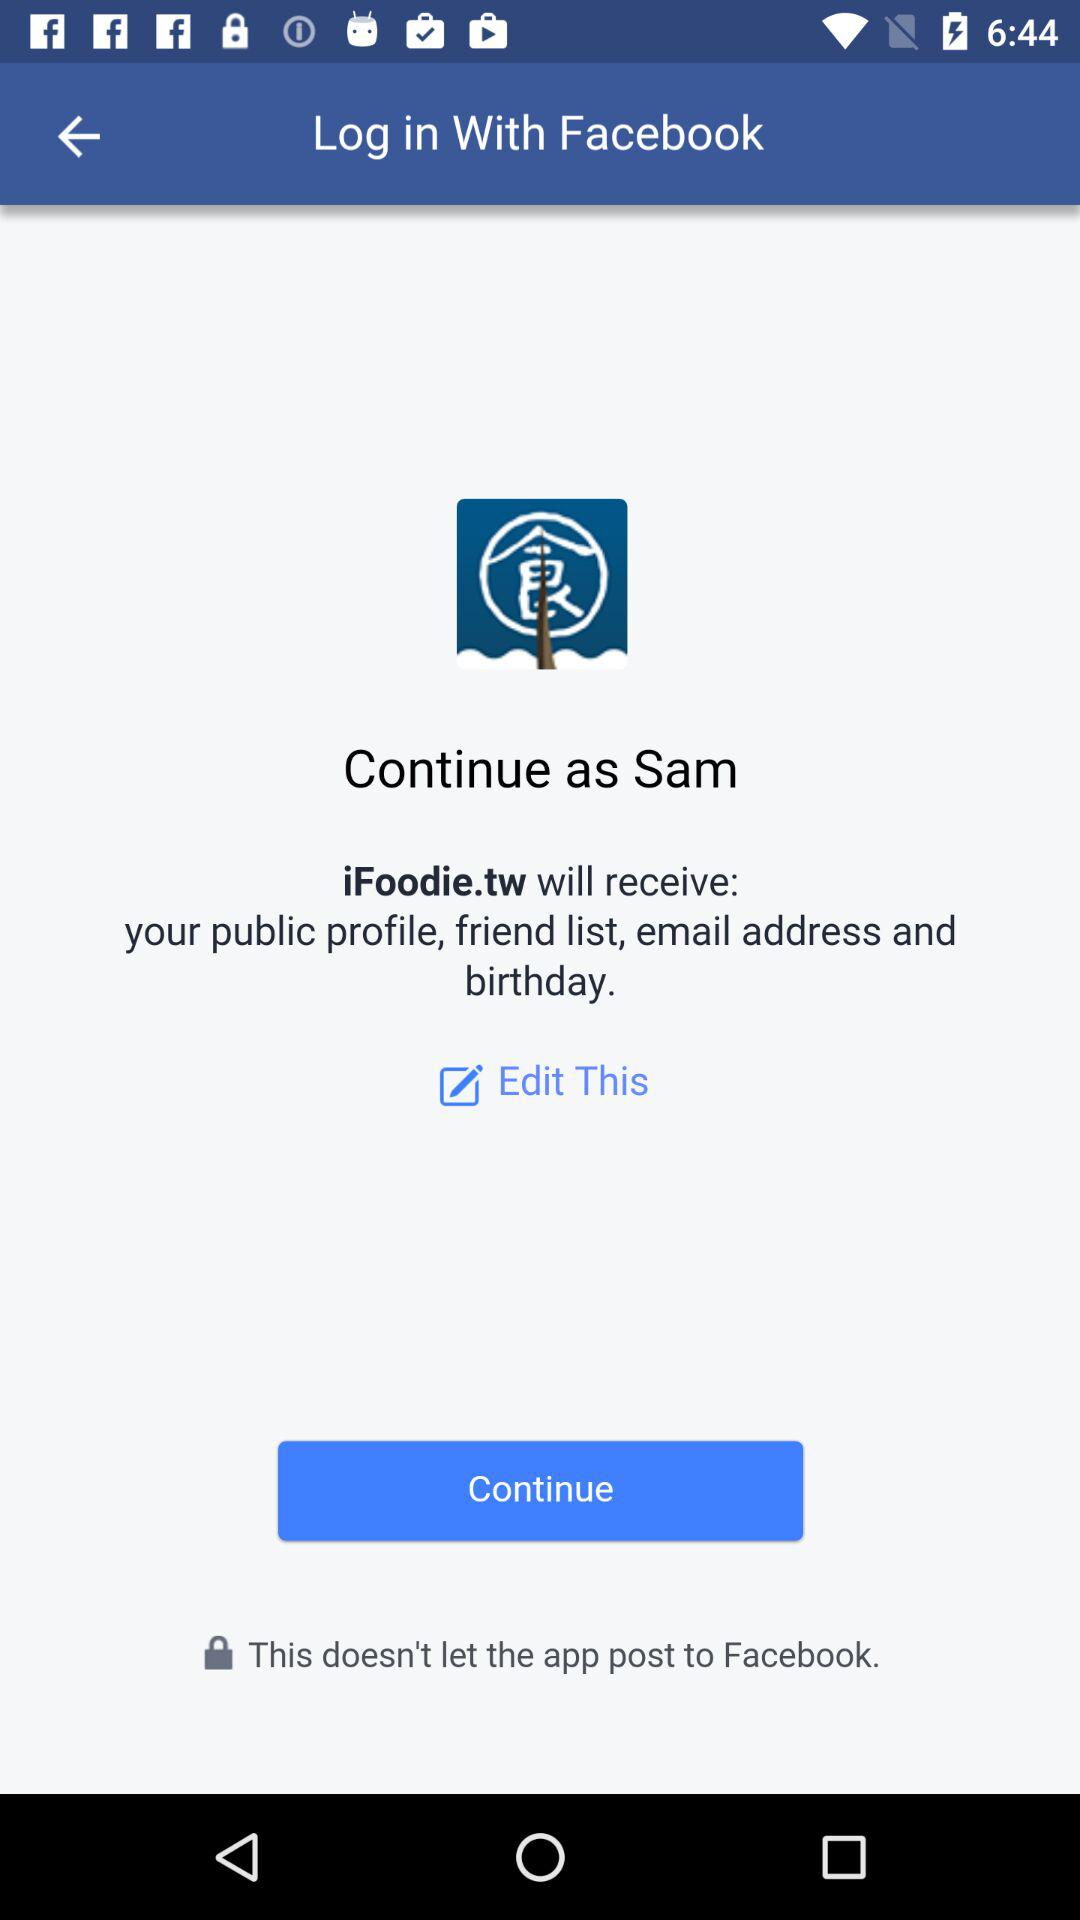What information will "iFoodie.tw" receive? "iFoodie.tw" will receive the public profile, friend list, email address and birthday. 